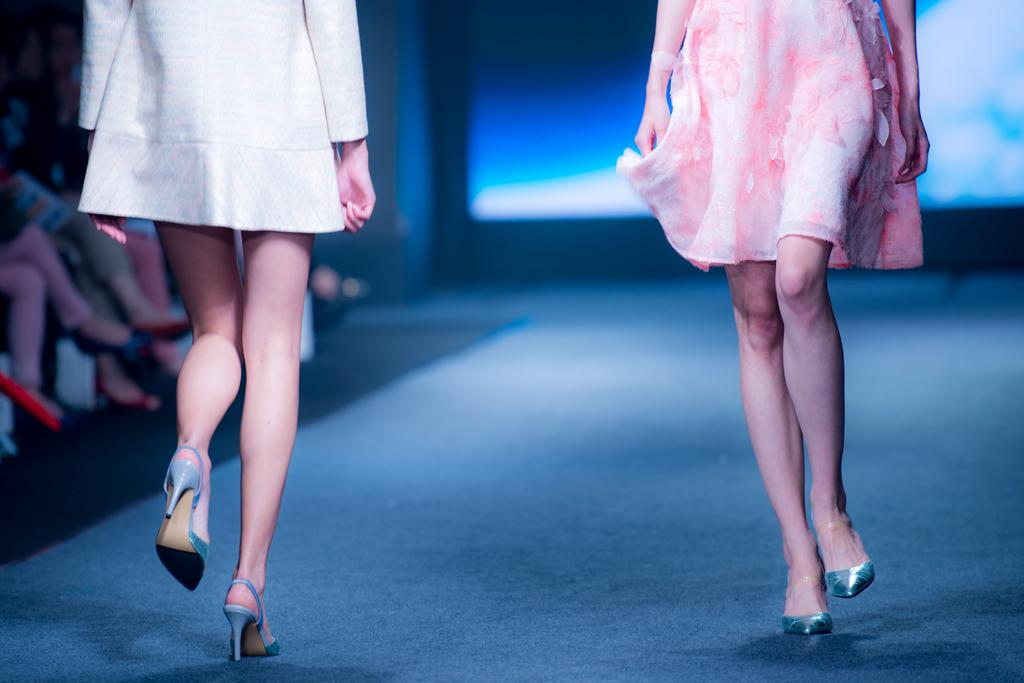What are the people in the image doing? The people in the image are walking on a ramp. Can you describe the surroundings of the ramp? There are other people visible in the background of the image. What object is present in the image that might display information? There is a screen present in the image. How many chickens can be seen on the dock in the image? There are no chickens or docks present in the image. 